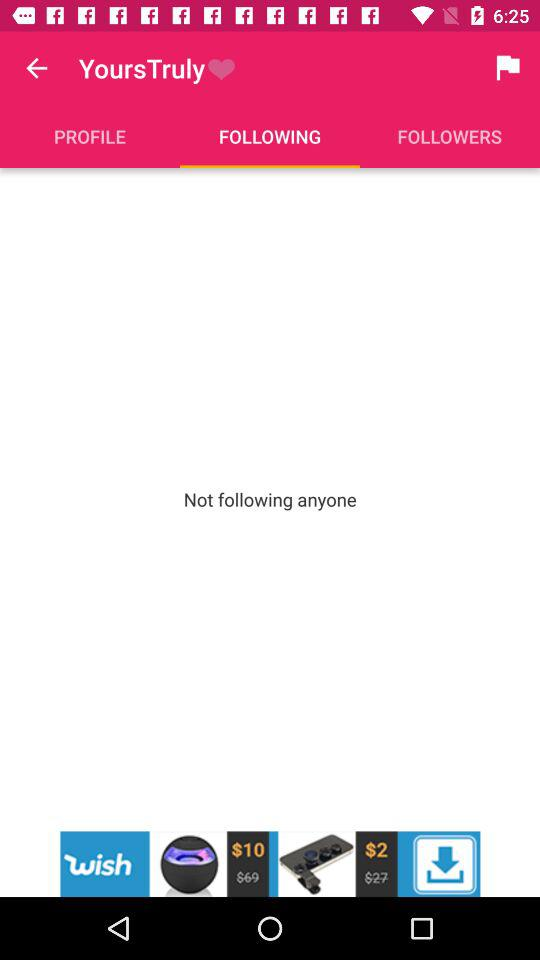Which tab is selected? The selected tab is "FOLLOWING". 